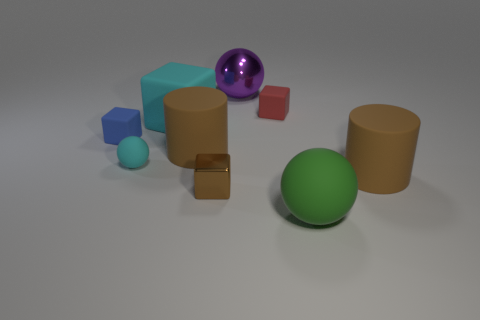Is the large cube the same color as the small matte ball?
Your answer should be very brief. Yes. What size is the sphere that is behind the tiny matte block on the right side of the cylinder to the left of the tiny red rubber object?
Your answer should be compact. Large. Does the tiny brown metallic thing have the same shape as the purple object?
Keep it short and to the point. No. There is a thing that is left of the tiny red object and behind the cyan rubber block; what size is it?
Your answer should be compact. Large. What is the material of the other large object that is the same shape as the red rubber object?
Provide a short and direct response. Rubber. What is the material of the tiny block on the left side of the cylinder on the left side of the shiny sphere?
Your answer should be compact. Rubber. There is a large green object; is its shape the same as the large brown object on the right side of the tiny red matte thing?
Provide a short and direct response. No. How many rubber objects are red objects or balls?
Ensure brevity in your answer.  3. There is a big ball in front of the large brown thing that is on the right side of the block that is in front of the blue rubber thing; what is its color?
Ensure brevity in your answer.  Green. What number of other things are there of the same material as the small cyan thing
Your answer should be very brief. 6. 